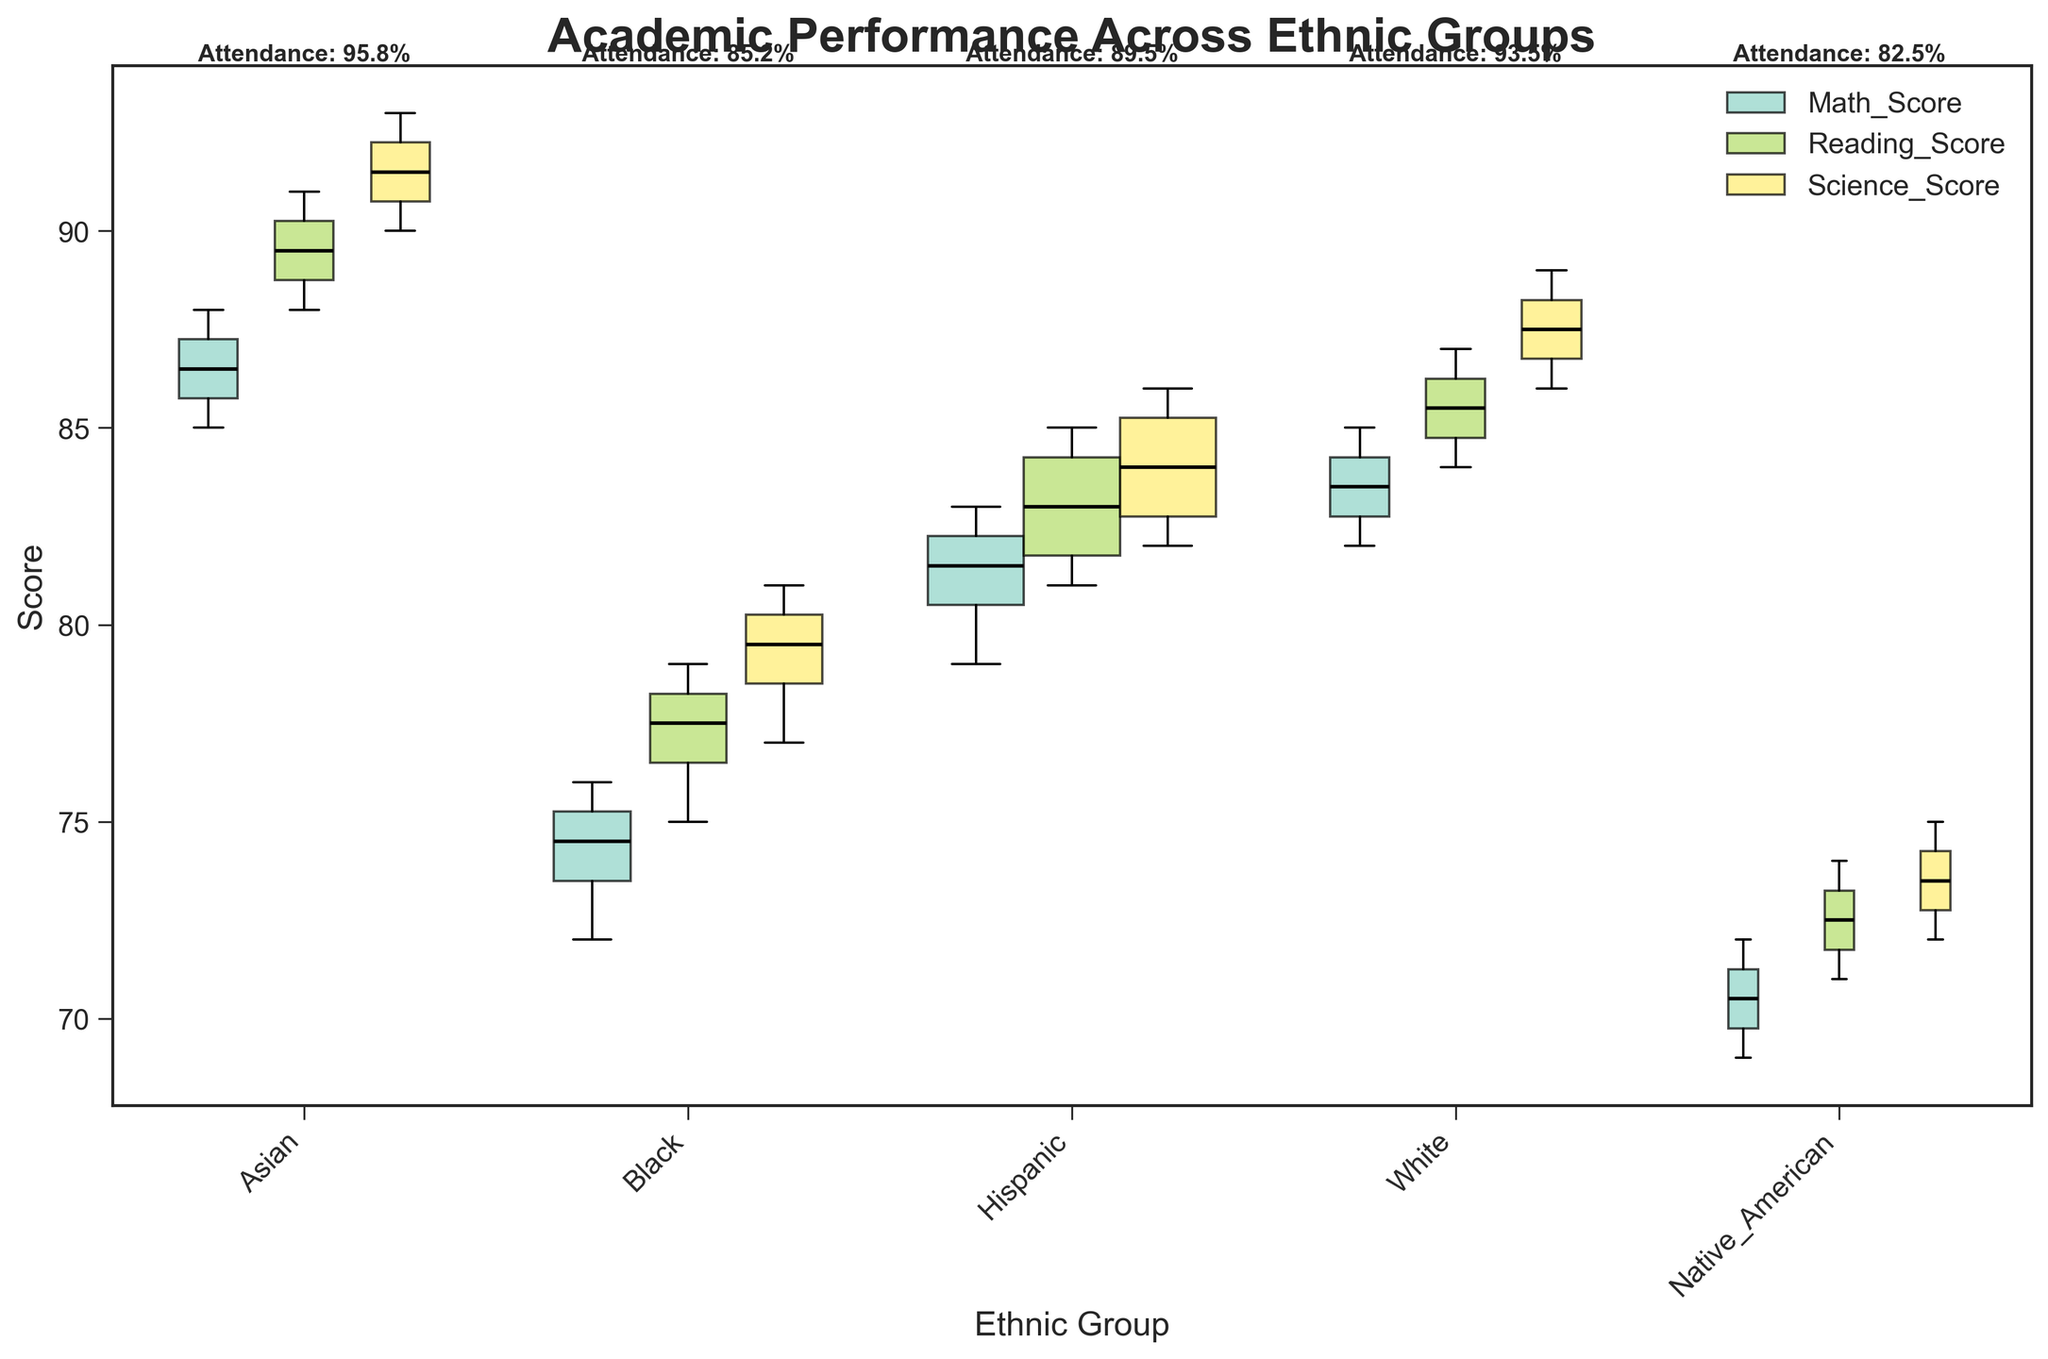What is the title of the plot? The title of the plot is displayed at the top center of the figure.
Answer: Academic Performance Across Ethnic Groups Which ethnic group has the highest attendance rate? Attendance rates are shown as text above each group's box plot. By comparing these values, we can see that the Asian group has the highest attendance rate.
Answer: Asian What is the lowest median score for Native American students, and in which subject? For the Native American students' box plots, identify the median lines for Math, Reading, and Science. The lowest median score is in Math.
Answer: Math, 70 Compare the median Science score of Asian and Black students. Which group performs better? Look at the median line (black, within the boxes) for Science scores of both Asian and Black students. Asian students have a higher median Science score.
Answer: Asian Which group has the widest variation in Math scores? Variability can be inferred from the length of the box and the whiskers. The Black group's box plot for Math scores shows the widest range.
Answer: Black What is the average attendance rate across all ethnic groups? The attendance rates for each ethnic group are Asian: 95.75%, Black: 85.25%, Hispanic: 89.5%, White: 93.5%, Native American: 82.5%. The average is calculated as (95.75+85.25+89.5+93.5+82.5)/5. The average is 89.30%.
Answer: 89.30% How does the average Reading score for Hispanic students compare to the average Reading score for White students? The Reading scores' median for each group gives us a comparison. The average given by the box plot for Hispanic is higher than White students.
Answer: Hispanic Which group has the smallest box plot width for Science scores, and what could this indicate? Widths represent the sample sizes, calculated for comparison. Native Americans have the smallest box plot width, indicating a smaller sample size for Science scores.
Answer: Native American What is the median Reading score for Hispanic students? Identify the median line inside the Reading score box plot for Hispanic students. It shows a median Reading score of approximately 83.
Answer: 83 Is there a positive relationship between attendance rates and academic performance in this plot? By observing the attendance rates and corresponding academic scores (median values and ranges), higher attendance generally aligns with better scores. However, correlation can't be confirmed without deeper statistical analysis.
Answer: Generally yes, with exceptions 